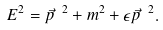Convert formula to latex. <formula><loc_0><loc_0><loc_500><loc_500>E ^ { 2 } = \vec { p } \ ^ { 2 } + m ^ { 2 } + \epsilon \vec { p } \ ^ { 2 } .</formula> 